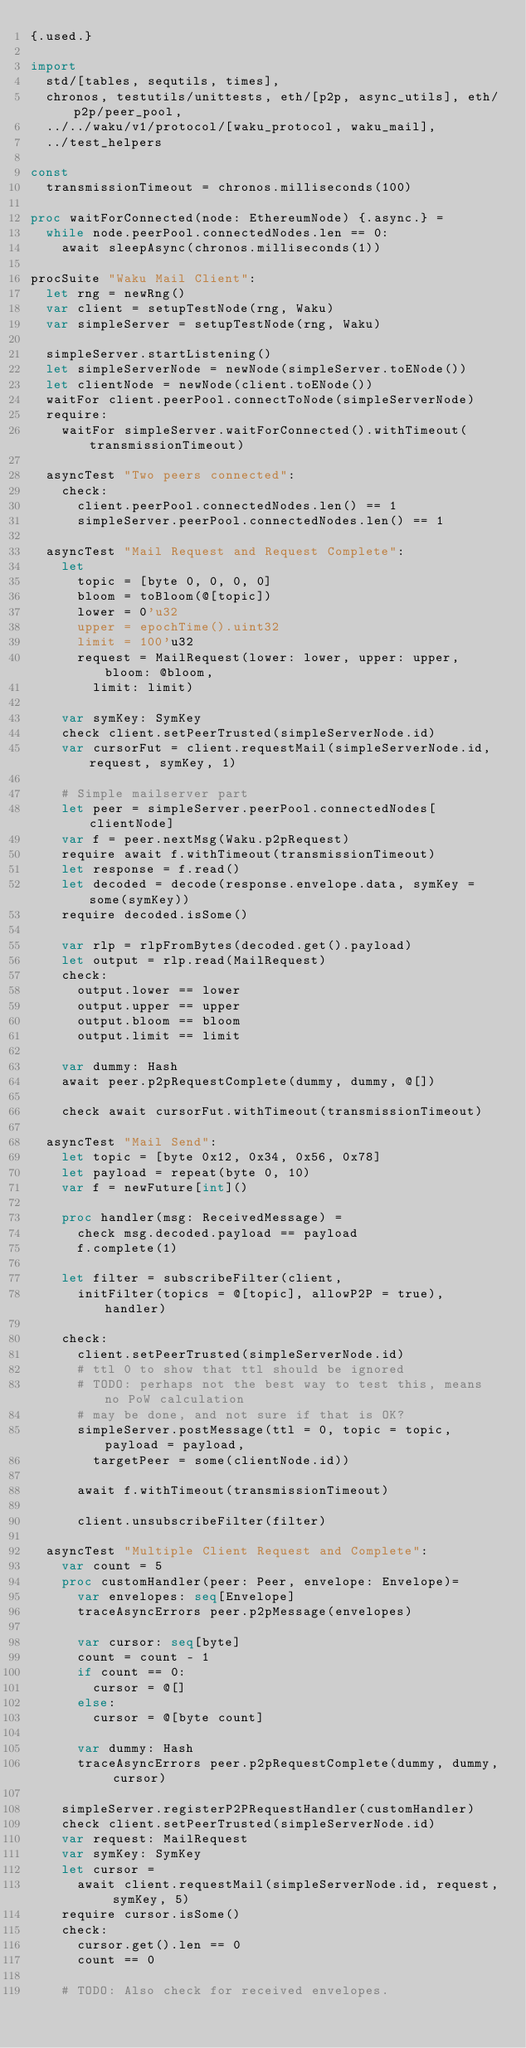<code> <loc_0><loc_0><loc_500><loc_500><_Nim_>{.used.}

import
  std/[tables, sequtils, times],
  chronos, testutils/unittests, eth/[p2p, async_utils], eth/p2p/peer_pool,
  ../../waku/v1/protocol/[waku_protocol, waku_mail],
  ../test_helpers

const
  transmissionTimeout = chronos.milliseconds(100)

proc waitForConnected(node: EthereumNode) {.async.} =
  while node.peerPool.connectedNodes.len == 0:
    await sleepAsync(chronos.milliseconds(1))

procSuite "Waku Mail Client":
  let rng = newRng()
  var client = setupTestNode(rng, Waku)
  var simpleServer = setupTestNode(rng, Waku)

  simpleServer.startListening()
  let simpleServerNode = newNode(simpleServer.toENode())
  let clientNode = newNode(client.toENode())
  waitFor client.peerPool.connectToNode(simpleServerNode)
  require:
    waitFor simpleServer.waitForConnected().withTimeout(transmissionTimeout)

  asyncTest "Two peers connected":
    check:
      client.peerPool.connectedNodes.len() == 1
      simpleServer.peerPool.connectedNodes.len() == 1

  asyncTest "Mail Request and Request Complete":
    let
      topic = [byte 0, 0, 0, 0]
      bloom = toBloom(@[topic])
      lower = 0'u32
      upper = epochTime().uint32
      limit = 100'u32
      request = MailRequest(lower: lower, upper: upper, bloom: @bloom,
        limit: limit)

    var symKey: SymKey
    check client.setPeerTrusted(simpleServerNode.id)
    var cursorFut = client.requestMail(simpleServerNode.id, request, symKey, 1)

    # Simple mailserver part
    let peer = simpleServer.peerPool.connectedNodes[clientNode]
    var f = peer.nextMsg(Waku.p2pRequest)
    require await f.withTimeout(transmissionTimeout)
    let response = f.read()
    let decoded = decode(response.envelope.data, symKey = some(symKey))
    require decoded.isSome()

    var rlp = rlpFromBytes(decoded.get().payload)
    let output = rlp.read(MailRequest)
    check:
      output.lower == lower
      output.upper == upper
      output.bloom == bloom
      output.limit == limit

    var dummy: Hash
    await peer.p2pRequestComplete(dummy, dummy, @[])

    check await cursorFut.withTimeout(transmissionTimeout)

  asyncTest "Mail Send":
    let topic = [byte 0x12, 0x34, 0x56, 0x78]
    let payload = repeat(byte 0, 10)
    var f = newFuture[int]()

    proc handler(msg: ReceivedMessage) =
      check msg.decoded.payload == payload
      f.complete(1)

    let filter = subscribeFilter(client,
      initFilter(topics = @[topic], allowP2P = true), handler)

    check:
      client.setPeerTrusted(simpleServerNode.id)
      # ttl 0 to show that ttl should be ignored
      # TODO: perhaps not the best way to test this, means no PoW calculation
      # may be done, and not sure if that is OK?
      simpleServer.postMessage(ttl = 0, topic = topic, payload = payload,
        targetPeer = some(clientNode.id))

      await f.withTimeout(transmissionTimeout)

      client.unsubscribeFilter(filter)

  asyncTest "Multiple Client Request and Complete":
    var count = 5
    proc customHandler(peer: Peer, envelope: Envelope)=
      var envelopes: seq[Envelope]
      traceAsyncErrors peer.p2pMessage(envelopes)

      var cursor: seq[byte]
      count = count - 1
      if count == 0:
        cursor = @[]
      else:
        cursor = @[byte count]

      var dummy: Hash
      traceAsyncErrors peer.p2pRequestComplete(dummy, dummy, cursor)

    simpleServer.registerP2PRequestHandler(customHandler)
    check client.setPeerTrusted(simpleServerNode.id)
    var request: MailRequest
    var symKey: SymKey
    let cursor =
      await client.requestMail(simpleServerNode.id, request, symKey, 5)
    require cursor.isSome()
    check:
      cursor.get().len == 0
      count == 0

    # TODO: Also check for received envelopes.
</code> 